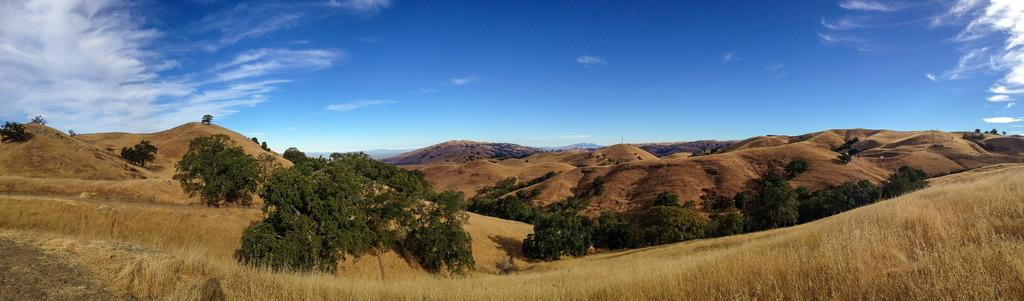What type of vegetation can be seen in the image? There are trees and plants in the image. What geographical feature is visible in the background of the image? There are mountains in the image. What type of ground cover is present in the image? There is grass in the image. What is visible at the top of the image? The sky is visible at the top of the image. What can be seen in the sky in the image? Clouds are present in the sky. What type of van can be seen driving through the mountains in the image? There is no van present in the image; it features trees, plants, mountains, grass, and clouds. How many ships are visible in the image? There are no ships present in the image. 